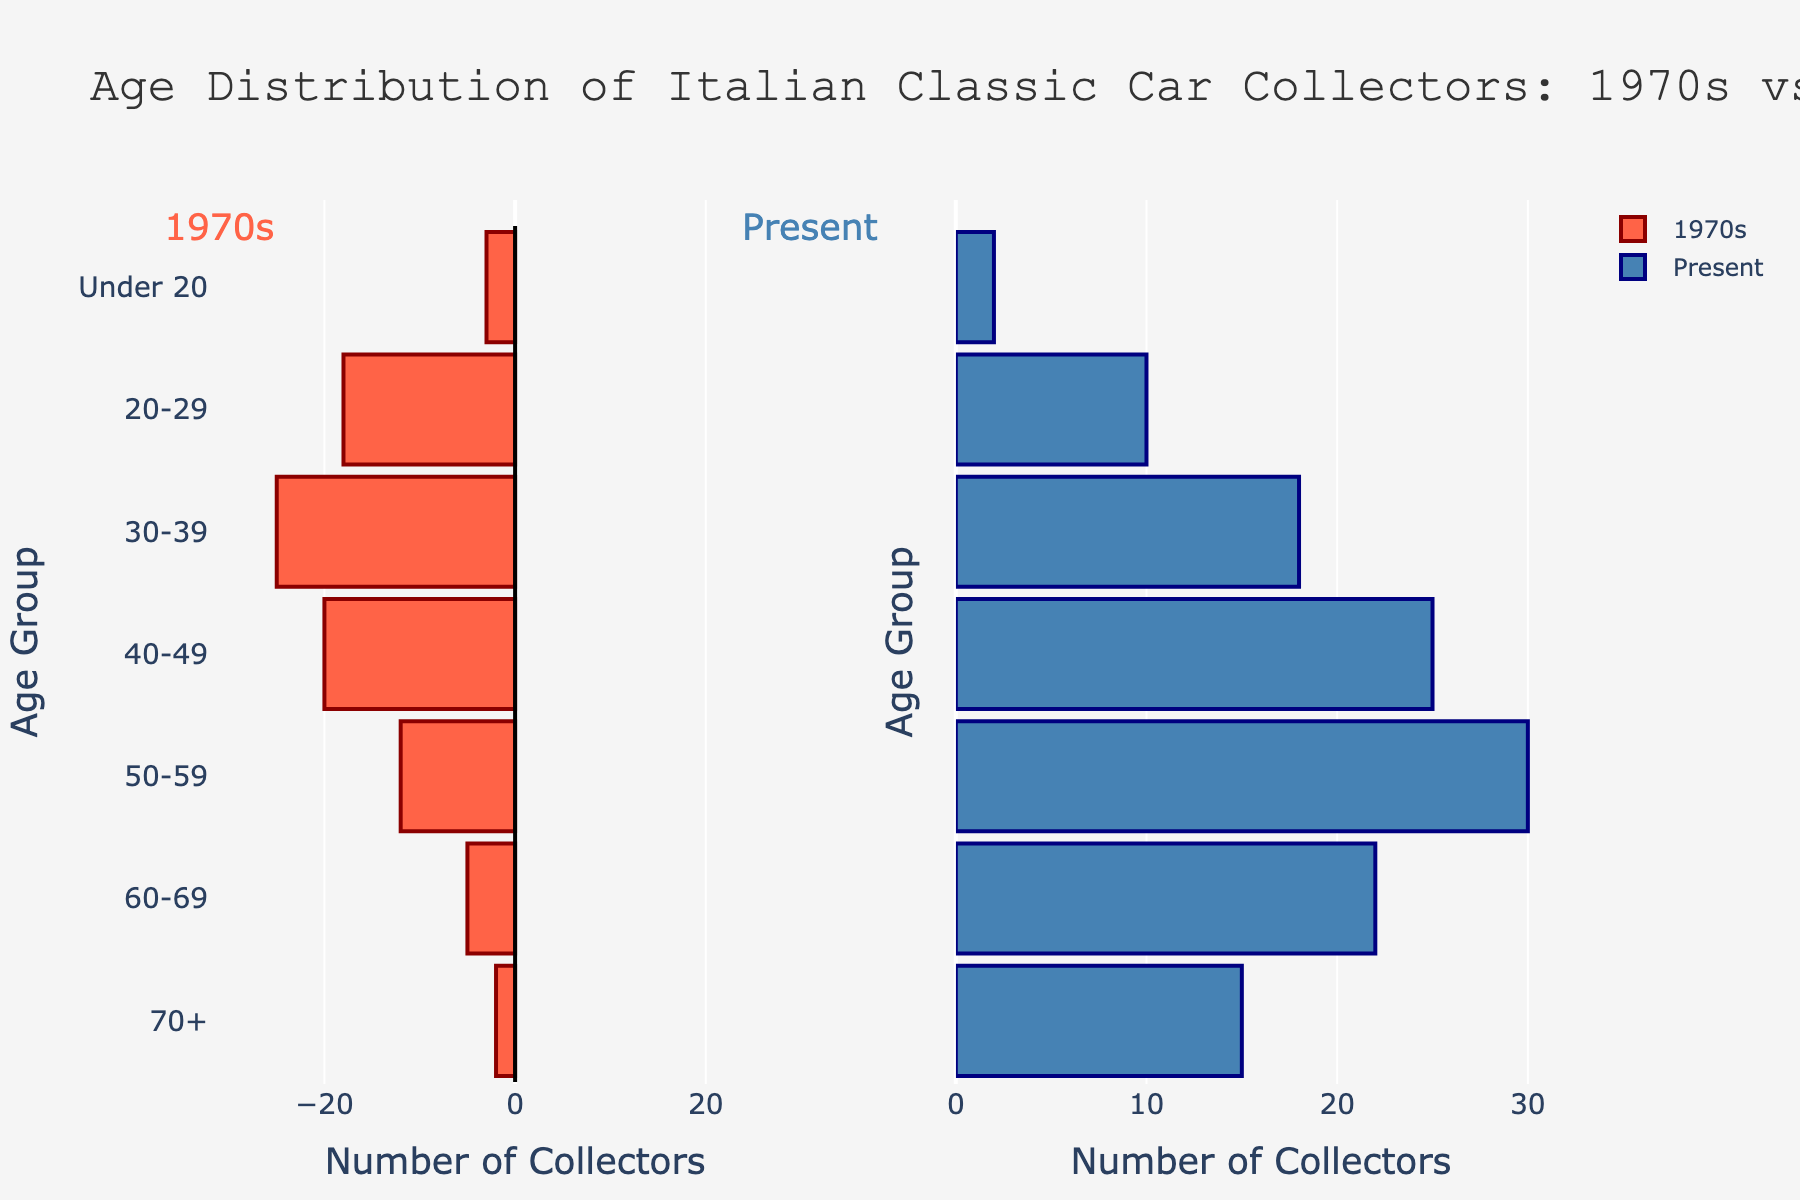what is the title of the figure? To identify the title, we look at the top of the figure where it is prominently displayed. The title is the text describing the overall content of the plot.
Answer: Age Distribution of Italian Classic Car Collectors: 1970s vs Present In the present, how many collectors are there in the 50-59 age group? Locate the bar on the right-hand side corresponding to the 50-59 age group and read its length, which represents the count of collectors.
Answer: 30 Which age group had the highest number of collectors in the 1970s? Compare the lengths of bars on the left-side of the plot to find the longest one, indicating the age group with the highest number of collectors.
Answer: 30-39 How many more collectors are there in the 60-69 age group now compared to the 1970s? Subtract the number of collectors in the 1970s from the number in the present for the 60-69 age group. (22 - 5)
Answer: 17 What is the total number of collectors in the present across all age groups? Sum the lengths of all bars on the right-hand side to get the total number of collectors in the present. (15 + 22 + 30 + 25 + 18 + 10 + 2)
Answer: 122 Which age group experienced the biggest decrease in collectors from the 1970s to the present? Compare the differences for each age group by subtracting the present numbers from the 1970s and identify the largest negative value.
Answer: 30-39 Has the number of collectors under 20 increased or decreased from the 1970s to the present? Compare the lengths of the bars for the 'Under 20' age group on both sides of the plot to determine if they have increased or decreased.
Answer: Decreased Which side of the plot has a vertical line at x=0? Identify the placement of the vertical line at x=0 within the plot, either on the left or right-hand side.
Answer: Left Are there more collectors aged 40-49 now than there were in the 1970s? Compare the lengths of the bars for the 40-49 age group on both the left and right sides of the plot to see which one is longer.
Answer: No What is the color of the bars representing the present age distribution? Look at the right-hand side of the plot to determine the color used for the bars representing the present age distribution.
Answer: Blue 